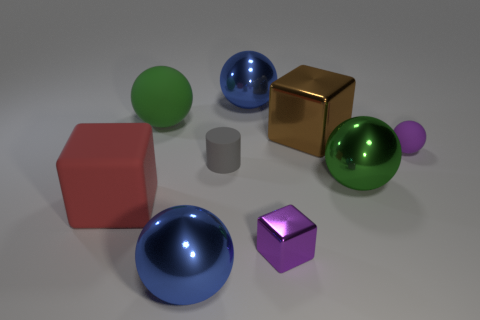What shape is the matte object that is the same color as the tiny metallic object? The matte object that shares its color with the tiny metallic object is a cylinder. This cylindrical shape is characterized by its circular base and elongated straight sides, which contrast with the spherical and cubical shapes of the other objects in the image. 